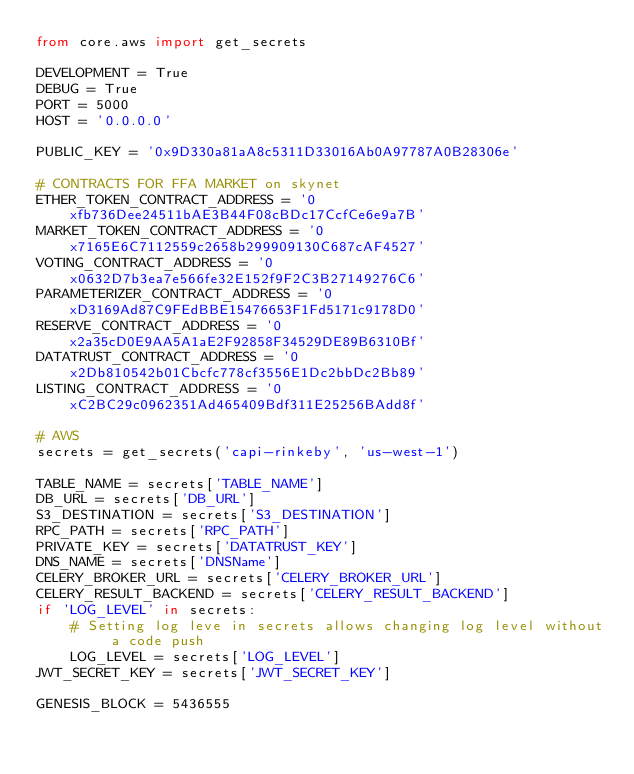<code> <loc_0><loc_0><loc_500><loc_500><_Python_>from core.aws import get_secrets

DEVELOPMENT = True
DEBUG = True
PORT = 5000
HOST = '0.0.0.0'

PUBLIC_KEY = '0x9D330a81aA8c5311D33016Ab0A97787A0B28306e'

# CONTRACTS FOR FFA MARKET on skynet
ETHER_TOKEN_CONTRACT_ADDRESS = '0xfb736Dee24511bAE3B44F08cBDc17CcfCe6e9a7B'
MARKET_TOKEN_CONTRACT_ADDRESS = '0x7165E6C7112559c2658b299909130C687cAF4527'
VOTING_CONTRACT_ADDRESS = '0x0632D7b3ea7e566fe32E152f9F2C3B27149276C6'
PARAMETERIZER_CONTRACT_ADDRESS = '0xD3169Ad87C9FEdBBE15476653F1Fd5171c9178D0'
RESERVE_CONTRACT_ADDRESS = '0x2a35cD0E9AA5A1aE2F92858F34529DE89B6310Bf'
DATATRUST_CONTRACT_ADDRESS = '0x2Db810542b01Cbcfc778cf3556E1Dc2bbDc2Bb89'
LISTING_CONTRACT_ADDRESS = '0xC2BC29c0962351Ad465409Bdf311E25256BAdd8f'

# AWS
secrets = get_secrets('capi-rinkeby', 'us-west-1')

TABLE_NAME = secrets['TABLE_NAME']
DB_URL = secrets['DB_URL']
S3_DESTINATION = secrets['S3_DESTINATION']
RPC_PATH = secrets['RPC_PATH']
PRIVATE_KEY = secrets['DATATRUST_KEY']
DNS_NAME = secrets['DNSName']
CELERY_BROKER_URL = secrets['CELERY_BROKER_URL']
CELERY_RESULT_BACKEND = secrets['CELERY_RESULT_BACKEND']
if 'LOG_LEVEL' in secrets:
    # Setting log leve in secrets allows changing log level without a code push
    LOG_LEVEL = secrets['LOG_LEVEL']
JWT_SECRET_KEY = secrets['JWT_SECRET_KEY']

GENESIS_BLOCK = 5436555
</code> 